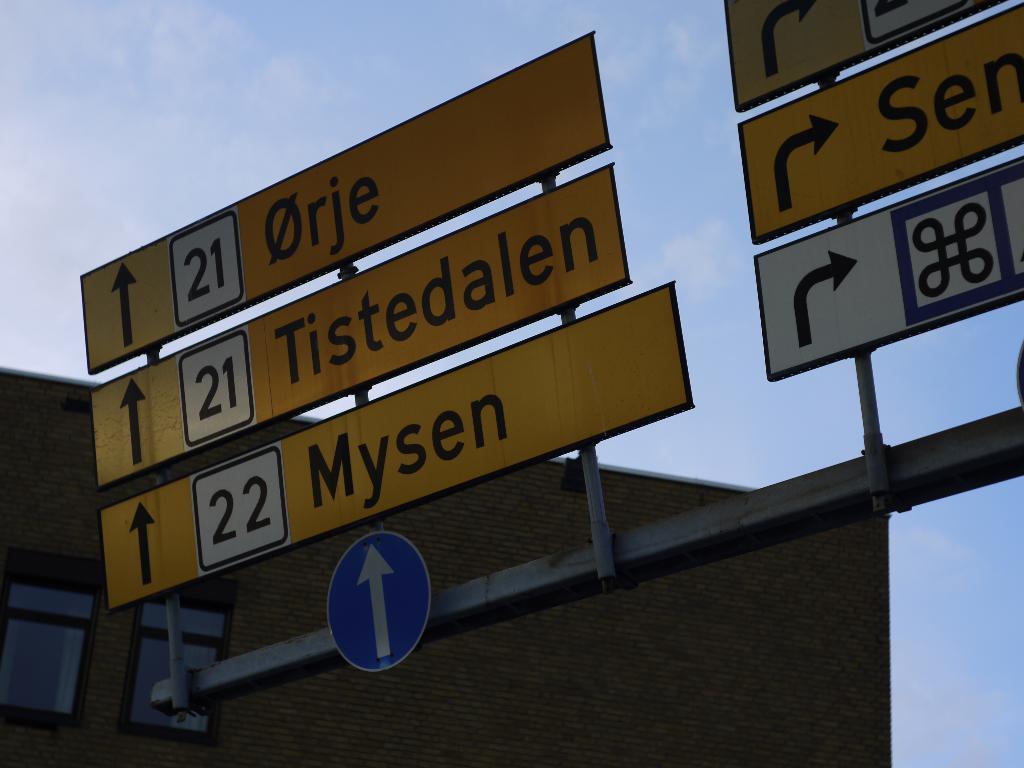Can you describe this image briefly? In the image in the center, we can see sign boards and we can see something written on it. In the background we can see the sky, clouds and building. 